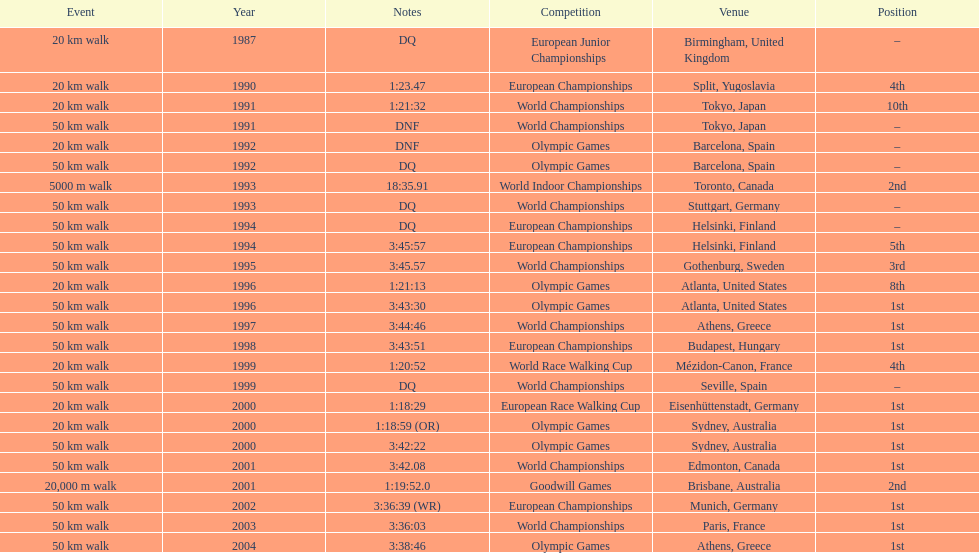What was the difference between korzeniowski's performance at the 1996 olympic games and the 2000 olympic games in the 20 km walk? 2:14. 